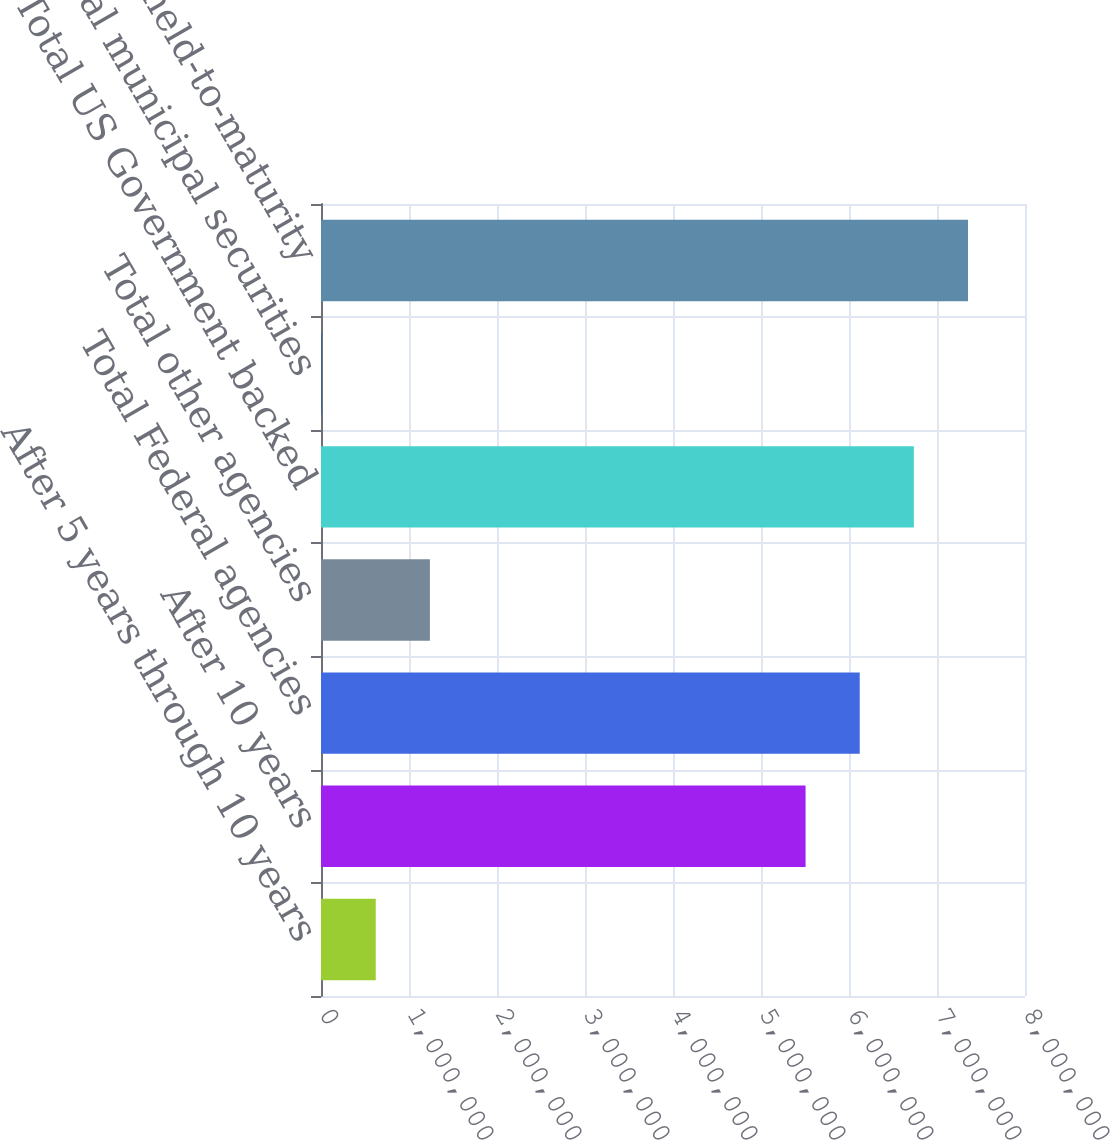Convert chart to OTSL. <chart><loc_0><loc_0><loc_500><loc_500><bar_chart><fcel>After 5 years through 10 years<fcel>After 10 years<fcel>Total Federal agencies<fcel>Total other agencies<fcel>Total US Government backed<fcel>Total municipal securities<fcel>Total held-to-maturity<nl><fcel>622292<fcel>5.50659e+06<fcel>6.12185e+06<fcel>1.23755e+06<fcel>6.7371e+06<fcel>7037<fcel>7.35236e+06<nl></chart> 